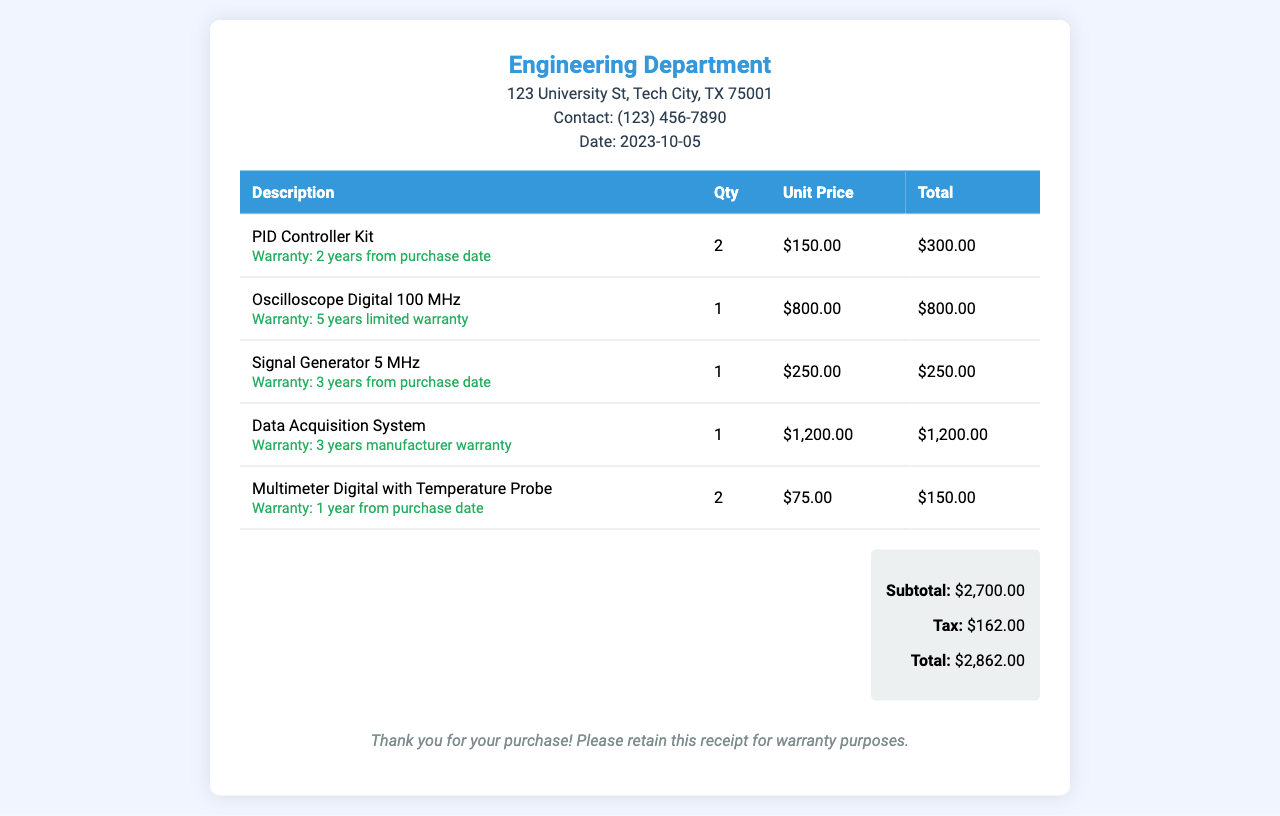What is the total cost of the PID Controller Kits? The total cost is calculated by multiplying the quantity of 2 by the unit price of $150.00, resulting in $300.00.
Answer: $300.00 What is the warranty duration for the Oscilloscope Digital? The warranty duration for the Oscilloscope Digital is stated as five years limited warranty.
Answer: 5 years How many items were purchased in total? The total number of items is the sum of the quantities of all equipment listed in the receipt: 2 + 1 + 1 + 1 + 2 = 7.
Answer: 7 What is the subtotal amount? The subtotal amount is indicated clearly in the summary section of the receipt as $2,700.00.
Answer: $2,700.00 What is the contact number for the Engineering Department? The contact number for the Engineering Department is provided in the document as (123) 456-7890.
Answer: (123) 456-7890 What is the total amount including tax? The total amount including tax is calculated in the summary section, which shows $2,862.00 as the total.
Answer: $2,862.00 What type of equipment is the Data Acquisition System? The receipt lists the Data Acquisition System as an equipment item, described directly in the document.
Answer: Data Acquisition System How many Digital Multimeters with Temperature Probe were purchased? The quantity of Digital Multimeter with Temperature Probe purchased is noted as 2 in the itemized list.
Answer: 2 